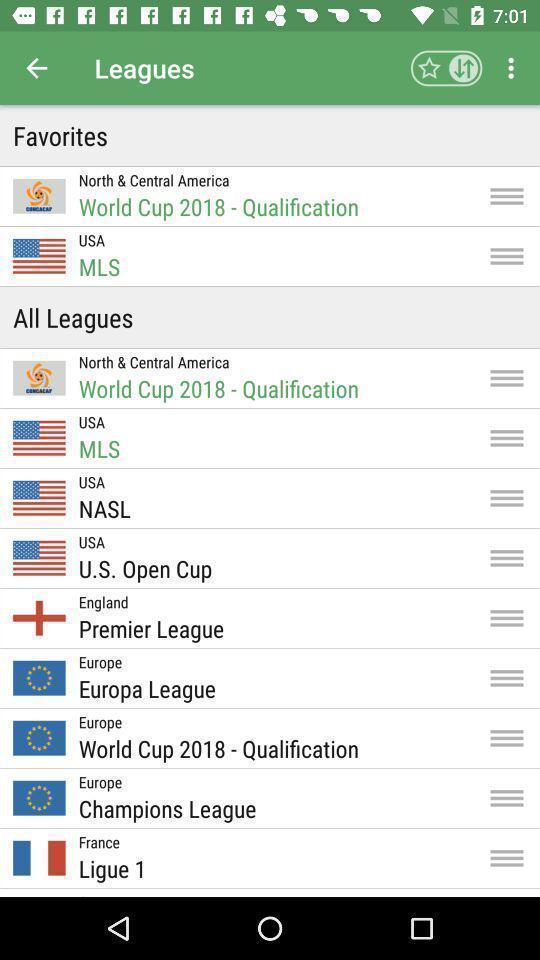Explain what's happening in this screen capture. Screen showing all leagues in an sports application. 